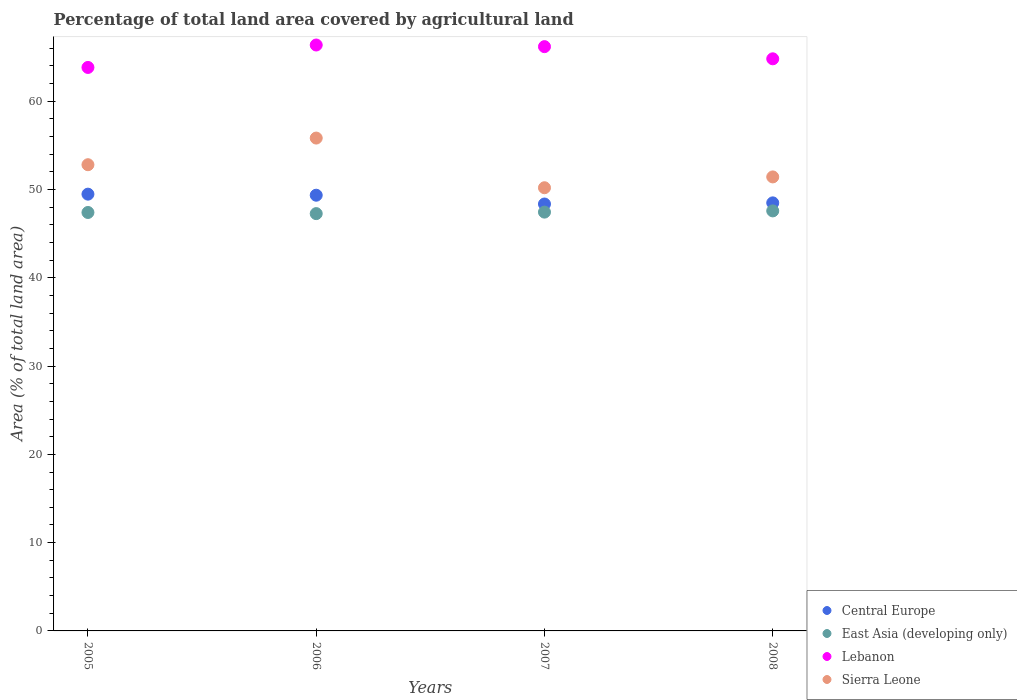What is the percentage of agricultural land in Lebanon in 2005?
Offer a terse response. 63.83. Across all years, what is the maximum percentage of agricultural land in East Asia (developing only)?
Your answer should be compact. 47.58. Across all years, what is the minimum percentage of agricultural land in East Asia (developing only)?
Make the answer very short. 47.27. In which year was the percentage of agricultural land in Central Europe minimum?
Provide a succinct answer. 2007. What is the total percentage of agricultural land in Central Europe in the graph?
Keep it short and to the point. 195.69. What is the difference between the percentage of agricultural land in Central Europe in 2005 and that in 2006?
Keep it short and to the point. 0.12. What is the difference between the percentage of agricultural land in Lebanon in 2005 and the percentage of agricultural land in Central Europe in 2008?
Your answer should be very brief. 15.34. What is the average percentage of agricultural land in Lebanon per year?
Provide a short and direct response. 65.3. In the year 2008, what is the difference between the percentage of agricultural land in East Asia (developing only) and percentage of agricultural land in Central Europe?
Give a very brief answer. -0.91. In how many years, is the percentage of agricultural land in Sierra Leone greater than 30 %?
Provide a succinct answer. 4. What is the ratio of the percentage of agricultural land in East Asia (developing only) in 2005 to that in 2007?
Offer a very short reply. 1. Is the difference between the percentage of agricultural land in East Asia (developing only) in 2005 and 2007 greater than the difference between the percentage of agricultural land in Central Europe in 2005 and 2007?
Give a very brief answer. No. What is the difference between the highest and the second highest percentage of agricultural land in Lebanon?
Provide a succinct answer. 0.19. What is the difference between the highest and the lowest percentage of agricultural land in Sierra Leone?
Give a very brief answer. 5.63. Is it the case that in every year, the sum of the percentage of agricultural land in East Asia (developing only) and percentage of agricultural land in Central Europe  is greater than the sum of percentage of agricultural land in Lebanon and percentage of agricultural land in Sierra Leone?
Your response must be concise. No. Is the percentage of agricultural land in East Asia (developing only) strictly less than the percentage of agricultural land in Central Europe over the years?
Offer a terse response. Yes. How many dotlines are there?
Offer a terse response. 4. How many years are there in the graph?
Your answer should be compact. 4. Does the graph contain any zero values?
Keep it short and to the point. No. How many legend labels are there?
Offer a terse response. 4. What is the title of the graph?
Provide a short and direct response. Percentage of total land area covered by agricultural land. What is the label or title of the Y-axis?
Provide a succinct answer. Area (% of total land area). What is the Area (% of total land area) of Central Europe in 2005?
Your answer should be compact. 49.48. What is the Area (% of total land area) in East Asia (developing only) in 2005?
Your response must be concise. 47.4. What is the Area (% of total land area) of Lebanon in 2005?
Make the answer very short. 63.83. What is the Area (% of total land area) in Sierra Leone in 2005?
Offer a terse response. 52.81. What is the Area (% of total land area) of Central Europe in 2006?
Provide a succinct answer. 49.36. What is the Area (% of total land area) in East Asia (developing only) in 2006?
Offer a terse response. 47.27. What is the Area (% of total land area) of Lebanon in 2006?
Ensure brevity in your answer.  66.37. What is the Area (% of total land area) of Sierra Leone in 2006?
Give a very brief answer. 55.83. What is the Area (% of total land area) of Central Europe in 2007?
Your answer should be compact. 48.36. What is the Area (% of total land area) in East Asia (developing only) in 2007?
Offer a terse response. 47.44. What is the Area (% of total land area) of Lebanon in 2007?
Your answer should be very brief. 66.19. What is the Area (% of total land area) of Sierra Leone in 2007?
Your answer should be very brief. 50.2. What is the Area (% of total land area) of Central Europe in 2008?
Provide a short and direct response. 48.49. What is the Area (% of total land area) in East Asia (developing only) in 2008?
Make the answer very short. 47.58. What is the Area (% of total land area) of Lebanon in 2008?
Provide a short and direct response. 64.81. What is the Area (% of total land area) of Sierra Leone in 2008?
Your response must be concise. 51.43. Across all years, what is the maximum Area (% of total land area) of Central Europe?
Your answer should be very brief. 49.48. Across all years, what is the maximum Area (% of total land area) in East Asia (developing only)?
Keep it short and to the point. 47.58. Across all years, what is the maximum Area (% of total land area) of Lebanon?
Ensure brevity in your answer.  66.37. Across all years, what is the maximum Area (% of total land area) in Sierra Leone?
Your response must be concise. 55.83. Across all years, what is the minimum Area (% of total land area) in Central Europe?
Provide a short and direct response. 48.36. Across all years, what is the minimum Area (% of total land area) in East Asia (developing only)?
Offer a terse response. 47.27. Across all years, what is the minimum Area (% of total land area) in Lebanon?
Make the answer very short. 63.83. Across all years, what is the minimum Area (% of total land area) of Sierra Leone?
Keep it short and to the point. 50.2. What is the total Area (% of total land area) in Central Europe in the graph?
Keep it short and to the point. 195.69. What is the total Area (% of total land area) of East Asia (developing only) in the graph?
Your answer should be very brief. 189.7. What is the total Area (% of total land area) of Lebanon in the graph?
Give a very brief answer. 261.2. What is the total Area (% of total land area) in Sierra Leone in the graph?
Your answer should be very brief. 210.28. What is the difference between the Area (% of total land area) in Central Europe in 2005 and that in 2006?
Offer a very short reply. 0.12. What is the difference between the Area (% of total land area) in East Asia (developing only) in 2005 and that in 2006?
Your response must be concise. 0.13. What is the difference between the Area (% of total land area) in Lebanon in 2005 and that in 2006?
Provide a short and direct response. -2.54. What is the difference between the Area (% of total land area) in Sierra Leone in 2005 and that in 2006?
Keep it short and to the point. -3.02. What is the difference between the Area (% of total land area) in Central Europe in 2005 and that in 2007?
Provide a succinct answer. 1.12. What is the difference between the Area (% of total land area) of East Asia (developing only) in 2005 and that in 2007?
Keep it short and to the point. -0.04. What is the difference between the Area (% of total land area) in Lebanon in 2005 and that in 2007?
Give a very brief answer. -2.36. What is the difference between the Area (% of total land area) of Sierra Leone in 2005 and that in 2007?
Make the answer very short. 2.61. What is the difference between the Area (% of total land area) in Central Europe in 2005 and that in 2008?
Your response must be concise. 0.99. What is the difference between the Area (% of total land area) of East Asia (developing only) in 2005 and that in 2008?
Make the answer very short. -0.18. What is the difference between the Area (% of total land area) in Lebanon in 2005 and that in 2008?
Your answer should be compact. -0.98. What is the difference between the Area (% of total land area) of Sierra Leone in 2005 and that in 2008?
Provide a short and direct response. 1.38. What is the difference between the Area (% of total land area) in East Asia (developing only) in 2006 and that in 2007?
Give a very brief answer. -0.17. What is the difference between the Area (% of total land area) in Lebanon in 2006 and that in 2007?
Offer a terse response. 0.19. What is the difference between the Area (% of total land area) in Sierra Leone in 2006 and that in 2007?
Offer a terse response. 5.63. What is the difference between the Area (% of total land area) in Central Europe in 2006 and that in 2008?
Your answer should be compact. 0.87. What is the difference between the Area (% of total land area) in East Asia (developing only) in 2006 and that in 2008?
Offer a very short reply. -0.31. What is the difference between the Area (% of total land area) in Lebanon in 2006 and that in 2008?
Give a very brief answer. 1.56. What is the difference between the Area (% of total land area) of Sierra Leone in 2006 and that in 2008?
Give a very brief answer. 4.4. What is the difference between the Area (% of total land area) in Central Europe in 2007 and that in 2008?
Keep it short and to the point. -0.13. What is the difference between the Area (% of total land area) of East Asia (developing only) in 2007 and that in 2008?
Keep it short and to the point. -0.14. What is the difference between the Area (% of total land area) of Lebanon in 2007 and that in 2008?
Give a very brief answer. 1.38. What is the difference between the Area (% of total land area) of Sierra Leone in 2007 and that in 2008?
Your answer should be compact. -1.23. What is the difference between the Area (% of total land area) of Central Europe in 2005 and the Area (% of total land area) of East Asia (developing only) in 2006?
Your answer should be compact. 2.21. What is the difference between the Area (% of total land area) of Central Europe in 2005 and the Area (% of total land area) of Lebanon in 2006?
Make the answer very short. -16.9. What is the difference between the Area (% of total land area) of Central Europe in 2005 and the Area (% of total land area) of Sierra Leone in 2006?
Your response must be concise. -6.35. What is the difference between the Area (% of total land area) of East Asia (developing only) in 2005 and the Area (% of total land area) of Lebanon in 2006?
Your answer should be compact. -18.97. What is the difference between the Area (% of total land area) of East Asia (developing only) in 2005 and the Area (% of total land area) of Sierra Leone in 2006?
Your answer should be very brief. -8.43. What is the difference between the Area (% of total land area) of Lebanon in 2005 and the Area (% of total land area) of Sierra Leone in 2006?
Give a very brief answer. 8. What is the difference between the Area (% of total land area) of Central Europe in 2005 and the Area (% of total land area) of East Asia (developing only) in 2007?
Your response must be concise. 2.04. What is the difference between the Area (% of total land area) of Central Europe in 2005 and the Area (% of total land area) of Lebanon in 2007?
Your answer should be compact. -16.71. What is the difference between the Area (% of total land area) of Central Europe in 2005 and the Area (% of total land area) of Sierra Leone in 2007?
Provide a short and direct response. -0.73. What is the difference between the Area (% of total land area) of East Asia (developing only) in 2005 and the Area (% of total land area) of Lebanon in 2007?
Provide a succinct answer. -18.79. What is the difference between the Area (% of total land area) in East Asia (developing only) in 2005 and the Area (% of total land area) in Sierra Leone in 2007?
Make the answer very short. -2.8. What is the difference between the Area (% of total land area) in Lebanon in 2005 and the Area (% of total land area) in Sierra Leone in 2007?
Your answer should be very brief. 13.63. What is the difference between the Area (% of total land area) of Central Europe in 2005 and the Area (% of total land area) of East Asia (developing only) in 2008?
Your response must be concise. 1.9. What is the difference between the Area (% of total land area) of Central Europe in 2005 and the Area (% of total land area) of Lebanon in 2008?
Keep it short and to the point. -15.33. What is the difference between the Area (% of total land area) in Central Europe in 2005 and the Area (% of total land area) in Sierra Leone in 2008?
Your response must be concise. -1.95. What is the difference between the Area (% of total land area) of East Asia (developing only) in 2005 and the Area (% of total land area) of Lebanon in 2008?
Give a very brief answer. -17.41. What is the difference between the Area (% of total land area) in East Asia (developing only) in 2005 and the Area (% of total land area) in Sierra Leone in 2008?
Ensure brevity in your answer.  -4.03. What is the difference between the Area (% of total land area) in Lebanon in 2005 and the Area (% of total land area) in Sierra Leone in 2008?
Provide a short and direct response. 12.4. What is the difference between the Area (% of total land area) of Central Europe in 2006 and the Area (% of total land area) of East Asia (developing only) in 2007?
Your answer should be very brief. 1.91. What is the difference between the Area (% of total land area) of Central Europe in 2006 and the Area (% of total land area) of Lebanon in 2007?
Your answer should be very brief. -16.83. What is the difference between the Area (% of total land area) of Central Europe in 2006 and the Area (% of total land area) of Sierra Leone in 2007?
Ensure brevity in your answer.  -0.85. What is the difference between the Area (% of total land area) of East Asia (developing only) in 2006 and the Area (% of total land area) of Lebanon in 2007?
Make the answer very short. -18.92. What is the difference between the Area (% of total land area) in East Asia (developing only) in 2006 and the Area (% of total land area) in Sierra Leone in 2007?
Your response must be concise. -2.93. What is the difference between the Area (% of total land area) in Lebanon in 2006 and the Area (% of total land area) in Sierra Leone in 2007?
Make the answer very short. 16.17. What is the difference between the Area (% of total land area) in Central Europe in 2006 and the Area (% of total land area) in East Asia (developing only) in 2008?
Ensure brevity in your answer.  1.78. What is the difference between the Area (% of total land area) in Central Europe in 2006 and the Area (% of total land area) in Lebanon in 2008?
Your answer should be compact. -15.45. What is the difference between the Area (% of total land area) in Central Europe in 2006 and the Area (% of total land area) in Sierra Leone in 2008?
Give a very brief answer. -2.07. What is the difference between the Area (% of total land area) in East Asia (developing only) in 2006 and the Area (% of total land area) in Lebanon in 2008?
Your answer should be very brief. -17.54. What is the difference between the Area (% of total land area) of East Asia (developing only) in 2006 and the Area (% of total land area) of Sierra Leone in 2008?
Offer a terse response. -4.16. What is the difference between the Area (% of total land area) of Lebanon in 2006 and the Area (% of total land area) of Sierra Leone in 2008?
Give a very brief answer. 14.94. What is the difference between the Area (% of total land area) of Central Europe in 2007 and the Area (% of total land area) of East Asia (developing only) in 2008?
Keep it short and to the point. 0.78. What is the difference between the Area (% of total land area) of Central Europe in 2007 and the Area (% of total land area) of Lebanon in 2008?
Provide a succinct answer. -16.45. What is the difference between the Area (% of total land area) in Central Europe in 2007 and the Area (% of total land area) in Sierra Leone in 2008?
Keep it short and to the point. -3.07. What is the difference between the Area (% of total land area) in East Asia (developing only) in 2007 and the Area (% of total land area) in Lebanon in 2008?
Make the answer very short. -17.37. What is the difference between the Area (% of total land area) in East Asia (developing only) in 2007 and the Area (% of total land area) in Sierra Leone in 2008?
Ensure brevity in your answer.  -3.99. What is the difference between the Area (% of total land area) of Lebanon in 2007 and the Area (% of total land area) of Sierra Leone in 2008?
Your answer should be very brief. 14.76. What is the average Area (% of total land area) in Central Europe per year?
Give a very brief answer. 48.92. What is the average Area (% of total land area) in East Asia (developing only) per year?
Ensure brevity in your answer.  47.42. What is the average Area (% of total land area) in Lebanon per year?
Provide a succinct answer. 65.3. What is the average Area (% of total land area) of Sierra Leone per year?
Offer a very short reply. 52.57. In the year 2005, what is the difference between the Area (% of total land area) in Central Europe and Area (% of total land area) in East Asia (developing only)?
Give a very brief answer. 2.08. In the year 2005, what is the difference between the Area (% of total land area) of Central Europe and Area (% of total land area) of Lebanon?
Offer a very short reply. -14.35. In the year 2005, what is the difference between the Area (% of total land area) of Central Europe and Area (% of total land area) of Sierra Leone?
Your answer should be very brief. -3.33. In the year 2005, what is the difference between the Area (% of total land area) of East Asia (developing only) and Area (% of total land area) of Lebanon?
Provide a succinct answer. -16.43. In the year 2005, what is the difference between the Area (% of total land area) of East Asia (developing only) and Area (% of total land area) of Sierra Leone?
Provide a succinct answer. -5.41. In the year 2005, what is the difference between the Area (% of total land area) in Lebanon and Area (% of total land area) in Sierra Leone?
Provide a short and direct response. 11.02. In the year 2006, what is the difference between the Area (% of total land area) in Central Europe and Area (% of total land area) in East Asia (developing only)?
Your answer should be very brief. 2.08. In the year 2006, what is the difference between the Area (% of total land area) of Central Europe and Area (% of total land area) of Lebanon?
Offer a terse response. -17.02. In the year 2006, what is the difference between the Area (% of total land area) in Central Europe and Area (% of total land area) in Sierra Leone?
Keep it short and to the point. -6.47. In the year 2006, what is the difference between the Area (% of total land area) of East Asia (developing only) and Area (% of total land area) of Lebanon?
Your answer should be very brief. -19.1. In the year 2006, what is the difference between the Area (% of total land area) in East Asia (developing only) and Area (% of total land area) in Sierra Leone?
Your answer should be very brief. -8.56. In the year 2006, what is the difference between the Area (% of total land area) in Lebanon and Area (% of total land area) in Sierra Leone?
Make the answer very short. 10.54. In the year 2007, what is the difference between the Area (% of total land area) in Central Europe and Area (% of total land area) in East Asia (developing only)?
Keep it short and to the point. 0.92. In the year 2007, what is the difference between the Area (% of total land area) of Central Europe and Area (% of total land area) of Lebanon?
Make the answer very short. -17.83. In the year 2007, what is the difference between the Area (% of total land area) of Central Europe and Area (% of total land area) of Sierra Leone?
Your answer should be very brief. -1.84. In the year 2007, what is the difference between the Area (% of total land area) in East Asia (developing only) and Area (% of total land area) in Lebanon?
Keep it short and to the point. -18.75. In the year 2007, what is the difference between the Area (% of total land area) in East Asia (developing only) and Area (% of total land area) in Sierra Leone?
Offer a terse response. -2.76. In the year 2007, what is the difference between the Area (% of total land area) of Lebanon and Area (% of total land area) of Sierra Leone?
Your answer should be very brief. 15.98. In the year 2008, what is the difference between the Area (% of total land area) in Central Europe and Area (% of total land area) in East Asia (developing only)?
Provide a succinct answer. 0.91. In the year 2008, what is the difference between the Area (% of total land area) in Central Europe and Area (% of total land area) in Lebanon?
Keep it short and to the point. -16.32. In the year 2008, what is the difference between the Area (% of total land area) of Central Europe and Area (% of total land area) of Sierra Leone?
Offer a terse response. -2.94. In the year 2008, what is the difference between the Area (% of total land area) in East Asia (developing only) and Area (% of total land area) in Lebanon?
Your answer should be compact. -17.23. In the year 2008, what is the difference between the Area (% of total land area) of East Asia (developing only) and Area (% of total land area) of Sierra Leone?
Provide a succinct answer. -3.85. In the year 2008, what is the difference between the Area (% of total land area) in Lebanon and Area (% of total land area) in Sierra Leone?
Offer a very short reply. 13.38. What is the ratio of the Area (% of total land area) in East Asia (developing only) in 2005 to that in 2006?
Ensure brevity in your answer.  1. What is the ratio of the Area (% of total land area) of Lebanon in 2005 to that in 2006?
Give a very brief answer. 0.96. What is the ratio of the Area (% of total land area) in Sierra Leone in 2005 to that in 2006?
Keep it short and to the point. 0.95. What is the ratio of the Area (% of total land area) in Central Europe in 2005 to that in 2007?
Your answer should be compact. 1.02. What is the ratio of the Area (% of total land area) of East Asia (developing only) in 2005 to that in 2007?
Keep it short and to the point. 1. What is the ratio of the Area (% of total land area) in Lebanon in 2005 to that in 2007?
Your response must be concise. 0.96. What is the ratio of the Area (% of total land area) in Sierra Leone in 2005 to that in 2007?
Give a very brief answer. 1.05. What is the ratio of the Area (% of total land area) in Central Europe in 2005 to that in 2008?
Offer a very short reply. 1.02. What is the ratio of the Area (% of total land area) of East Asia (developing only) in 2005 to that in 2008?
Ensure brevity in your answer.  1. What is the ratio of the Area (% of total land area) of Lebanon in 2005 to that in 2008?
Your answer should be very brief. 0.98. What is the ratio of the Area (% of total land area) of Sierra Leone in 2005 to that in 2008?
Keep it short and to the point. 1.03. What is the ratio of the Area (% of total land area) in Central Europe in 2006 to that in 2007?
Give a very brief answer. 1.02. What is the ratio of the Area (% of total land area) in East Asia (developing only) in 2006 to that in 2007?
Offer a very short reply. 1. What is the ratio of the Area (% of total land area) of Lebanon in 2006 to that in 2007?
Provide a short and direct response. 1. What is the ratio of the Area (% of total land area) in Sierra Leone in 2006 to that in 2007?
Your response must be concise. 1.11. What is the ratio of the Area (% of total land area) of Central Europe in 2006 to that in 2008?
Provide a short and direct response. 1.02. What is the ratio of the Area (% of total land area) of East Asia (developing only) in 2006 to that in 2008?
Give a very brief answer. 0.99. What is the ratio of the Area (% of total land area) in Lebanon in 2006 to that in 2008?
Offer a terse response. 1.02. What is the ratio of the Area (% of total land area) in Sierra Leone in 2006 to that in 2008?
Offer a terse response. 1.09. What is the ratio of the Area (% of total land area) in Central Europe in 2007 to that in 2008?
Your response must be concise. 1. What is the ratio of the Area (% of total land area) in Lebanon in 2007 to that in 2008?
Your answer should be compact. 1.02. What is the ratio of the Area (% of total land area) of Sierra Leone in 2007 to that in 2008?
Make the answer very short. 0.98. What is the difference between the highest and the second highest Area (% of total land area) in Central Europe?
Provide a short and direct response. 0.12. What is the difference between the highest and the second highest Area (% of total land area) in East Asia (developing only)?
Your response must be concise. 0.14. What is the difference between the highest and the second highest Area (% of total land area) of Lebanon?
Your answer should be compact. 0.19. What is the difference between the highest and the second highest Area (% of total land area) of Sierra Leone?
Make the answer very short. 3.02. What is the difference between the highest and the lowest Area (% of total land area) of Central Europe?
Provide a short and direct response. 1.12. What is the difference between the highest and the lowest Area (% of total land area) in East Asia (developing only)?
Offer a very short reply. 0.31. What is the difference between the highest and the lowest Area (% of total land area) in Lebanon?
Ensure brevity in your answer.  2.54. What is the difference between the highest and the lowest Area (% of total land area) in Sierra Leone?
Your response must be concise. 5.63. 